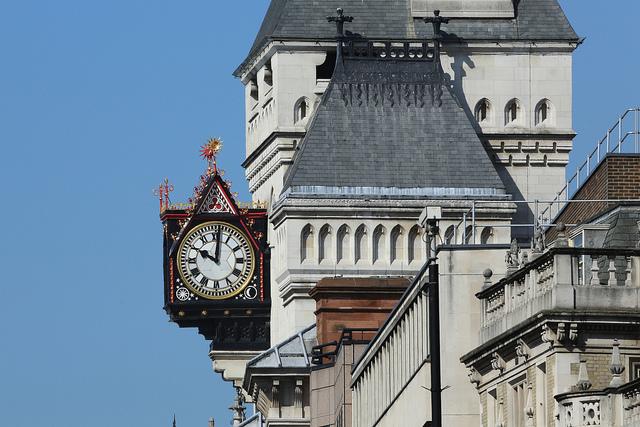What time is shown?
Keep it brief. 10:00. What time is it?
Be succinct. 10. Is it cloudy?
Be succinct. No. What time does the clock say?
Quick response, please. 10:00. What time does the clock show?
Give a very brief answer. 10:01. Is this a cloudy day?
Give a very brief answer. No. What color is the sky?
Short answer required. Blue. What color are the rooftops?
Write a very short answer. Gray. Is this the Eiffel Tower?
Give a very brief answer. No. What time does the clock read?
Answer briefly. 10:00. What time period were the two structures built?
Quick response, please. 1800s. Is this a modern clock?
Give a very brief answer. No. What time is on the clock?
Short answer required. 10:00. What is above the clock?
Be succinct. Pinwheel. What time is it according to the clock in the picture?
Be succinct. 10:00. 